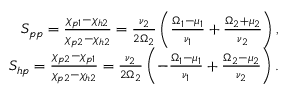Convert formula to latex. <formula><loc_0><loc_0><loc_500><loc_500>\begin{array} { r l r } & { S _ { p p } = \frac { \chi _ { p 1 } - \chi _ { h 2 } } { \chi _ { p 2 } - \chi _ { h 2 } } = \frac { \nu _ { 2 } } { 2 \Omega _ { 2 } } \left ( \frac { \Omega _ { 1 } - \mu _ { 1 } } { \nu _ { 1 } } + \frac { \Omega _ { 2 } + \mu _ { 2 } } { \nu _ { 2 } } \right ) , } \\ & { S _ { h p } = \frac { \chi _ { p 2 } - \chi _ { p 1 } } { \chi _ { p 2 } - \chi _ { h 2 } } = \frac { \nu _ { 2 } } { 2 \Omega _ { 2 } } \left ( - \frac { \Omega _ { 1 } - \mu _ { 1 } } { \nu _ { 1 } } + \frac { \Omega _ { 2 } - \mu _ { 2 } } { \nu _ { 2 } } \right ) . } \end{array}</formula> 